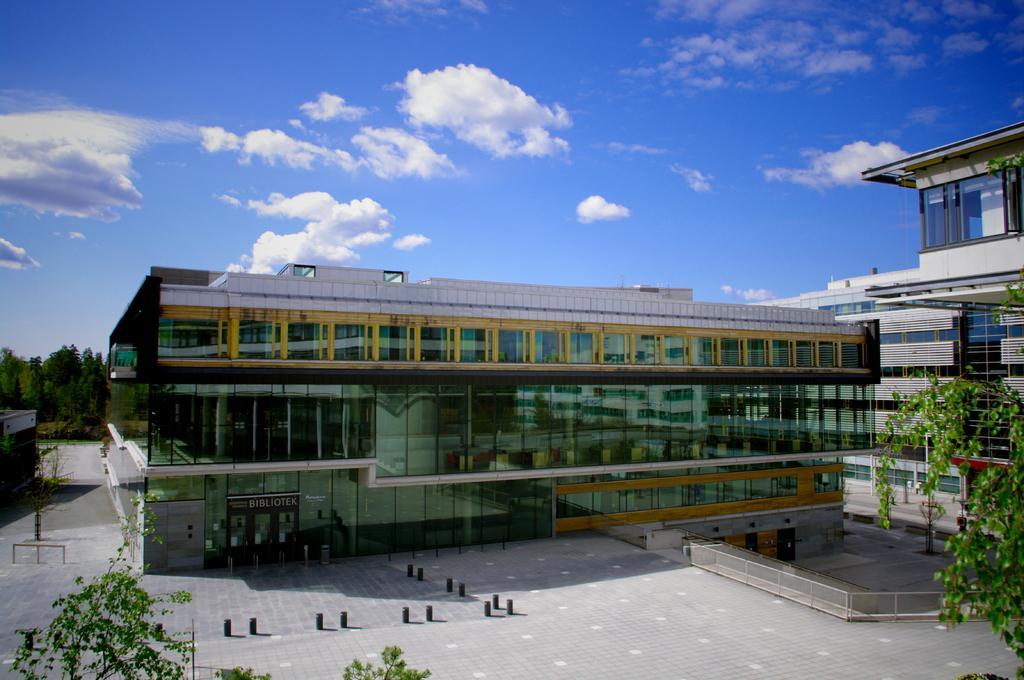Describe this image in one or two sentences. In this picture we can see buildings, on the right side and left side there are trees, we can see glasses of this building, there is the sky and clouds at the top of the picture. 